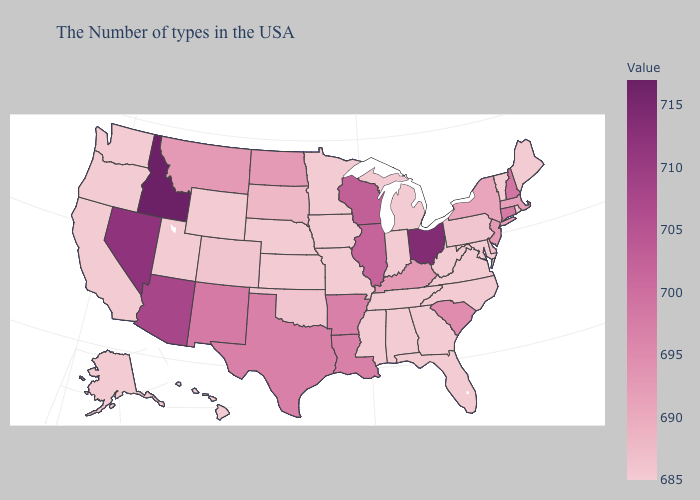Does New Hampshire have the lowest value in the USA?
Write a very short answer. No. Does the map have missing data?
Keep it brief. No. Does Kansas have the lowest value in the MidWest?
Short answer required. Yes. Which states have the lowest value in the USA?
Answer briefly. Maine, Rhode Island, Vermont, Maryland, Virginia, North Carolina, West Virginia, Florida, Georgia, Michigan, Indiana, Alabama, Tennessee, Mississippi, Missouri, Minnesota, Iowa, Kansas, Nebraska, Wyoming, Utah, California, Washington, Oregon, Alaska, Hawaii. Among the states that border Idaho , which have the highest value?
Be succinct. Nevada. Does Indiana have the lowest value in the USA?
Answer briefly. Yes. Which states have the lowest value in the MidWest?
Give a very brief answer. Michigan, Indiana, Missouri, Minnesota, Iowa, Kansas, Nebraska. Among the states that border Wyoming , does Montana have the highest value?
Write a very short answer. No. 